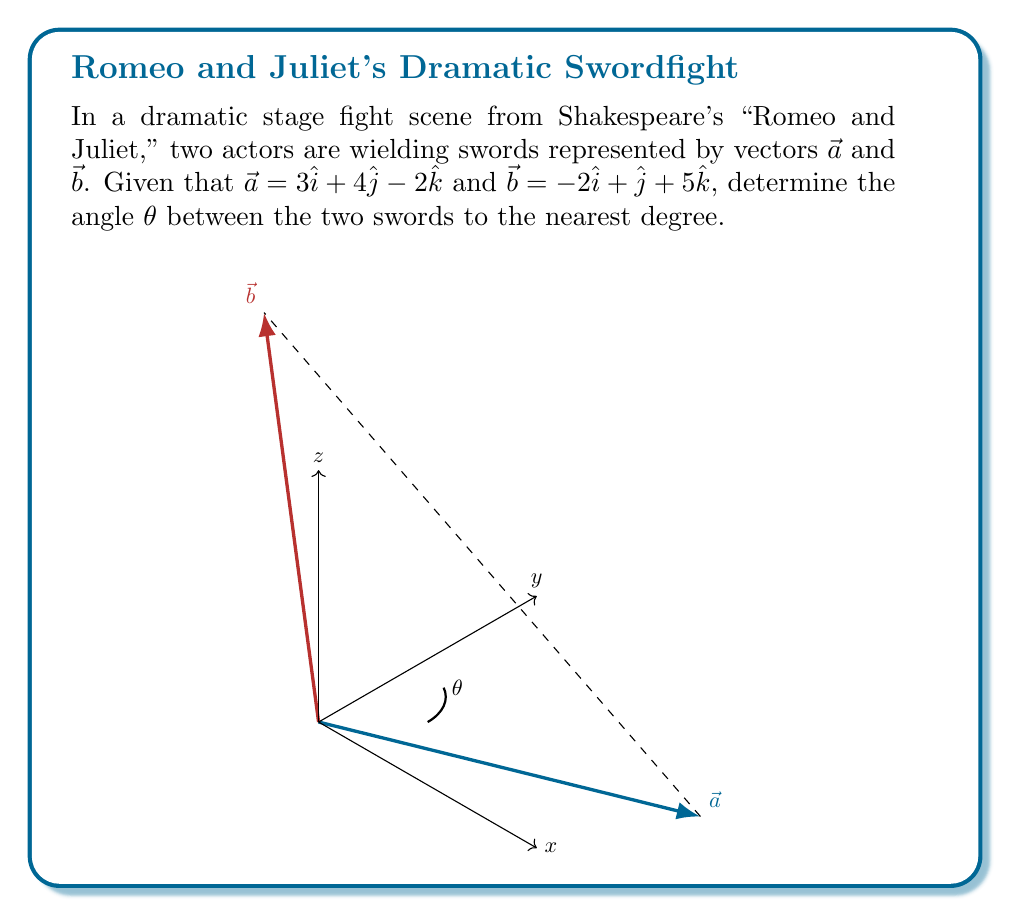Teach me how to tackle this problem. To find the angle between two vectors, we can use the dot product formula:

$$\cos \theta = \frac{\vec{a} \cdot \vec{b}}{|\vec{a}||\vec{b}|}$$

Step 1: Calculate the dot product $\vec{a} \cdot \vec{b}$
$$\vec{a} \cdot \vec{b} = (3)(-2) + (4)(1) + (-2)(5) = -6 + 4 - 10 = -12$$

Step 2: Calculate the magnitudes of $\vec{a}$ and $\vec{b}$
$$|\vec{a}| = \sqrt{3^2 + 4^2 + (-2)^2} = \sqrt{9 + 16 + 4} = \sqrt{29}$$
$$|\vec{b}| = \sqrt{(-2)^2 + 1^2 + 5^2} = \sqrt{4 + 1 + 25} = \sqrt{30}$$

Step 3: Substitute into the formula
$$\cos \theta = \frac{-12}{\sqrt{29}\sqrt{30}}$$

Step 4: Calculate $\theta$ using inverse cosine
$$\theta = \arccos\left(\frac{-12}{\sqrt{29}\sqrt{30}}\right)$$

Step 5: Convert to degrees and round to the nearest degree
$$\theta \approx 117°$$
Answer: 117° 